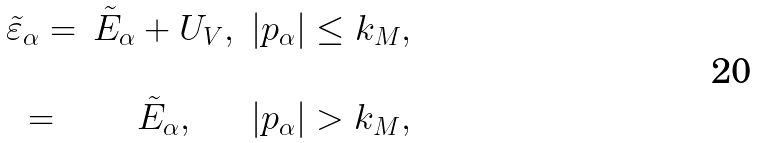<formula> <loc_0><loc_0><loc_500><loc_500>\begin{array} { c c c } \tilde { \varepsilon } _ { \alpha } = & \tilde { E } _ { \alpha } + U _ { V } , & | { p } _ { \alpha } | \leq k _ { M } , \\ & & \\ = & \tilde { E } _ { \alpha } , & | { p } _ { \alpha } | > k _ { M } , \\ \end{array}</formula> 